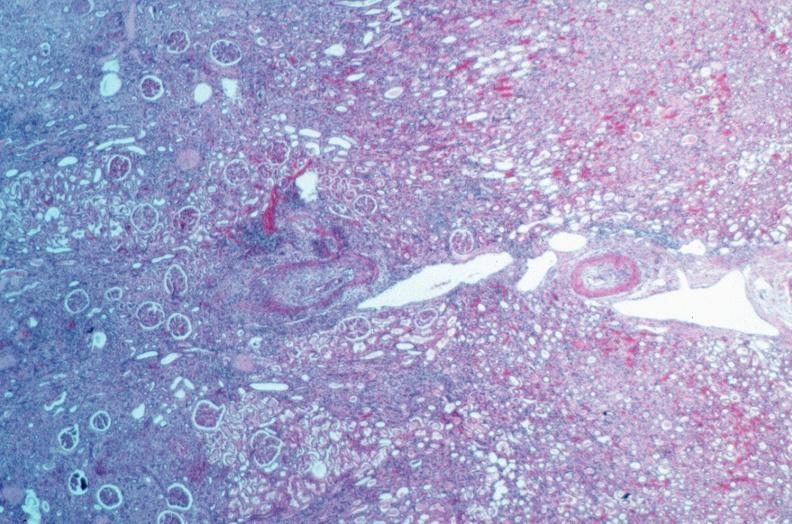s vasculature present?
Answer the question using a single word or phrase. Yes 